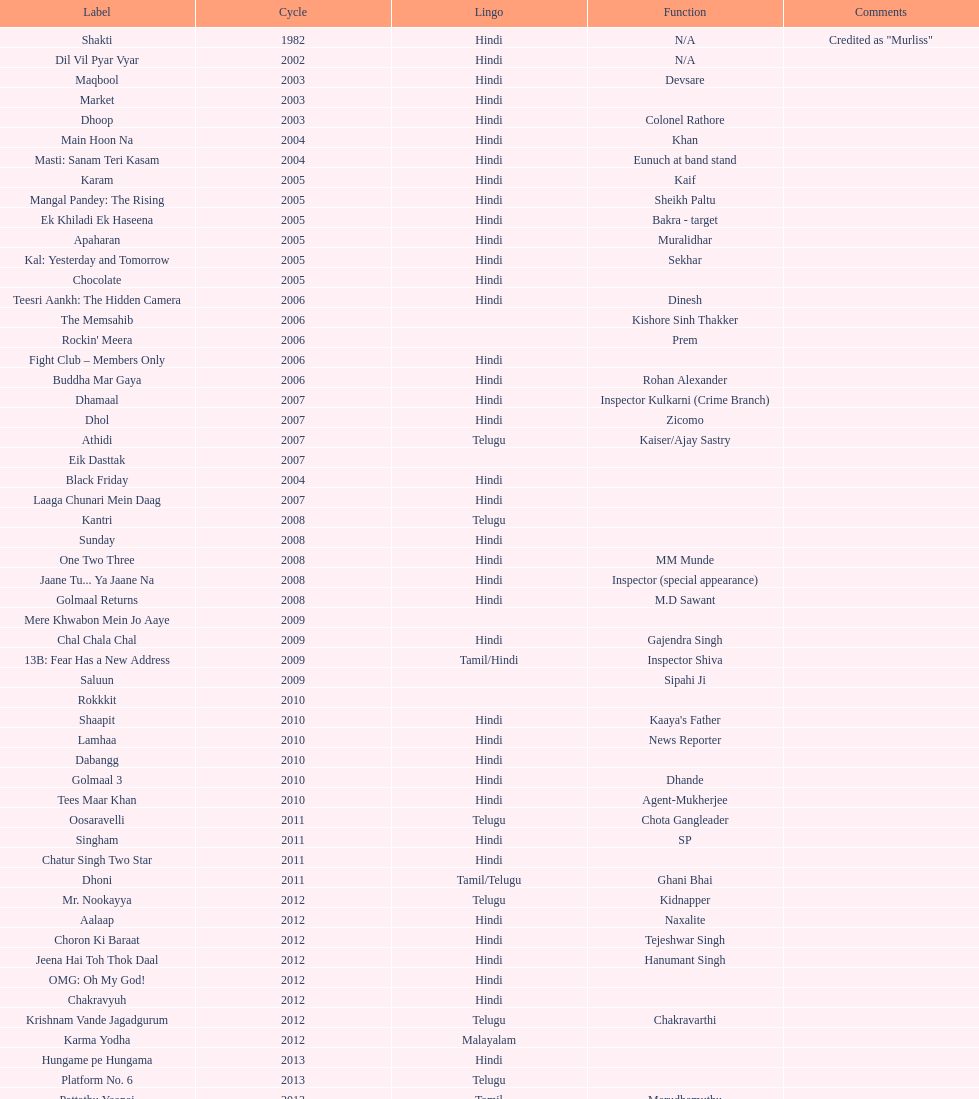Does maqbool have longer notes than shakti? No. 